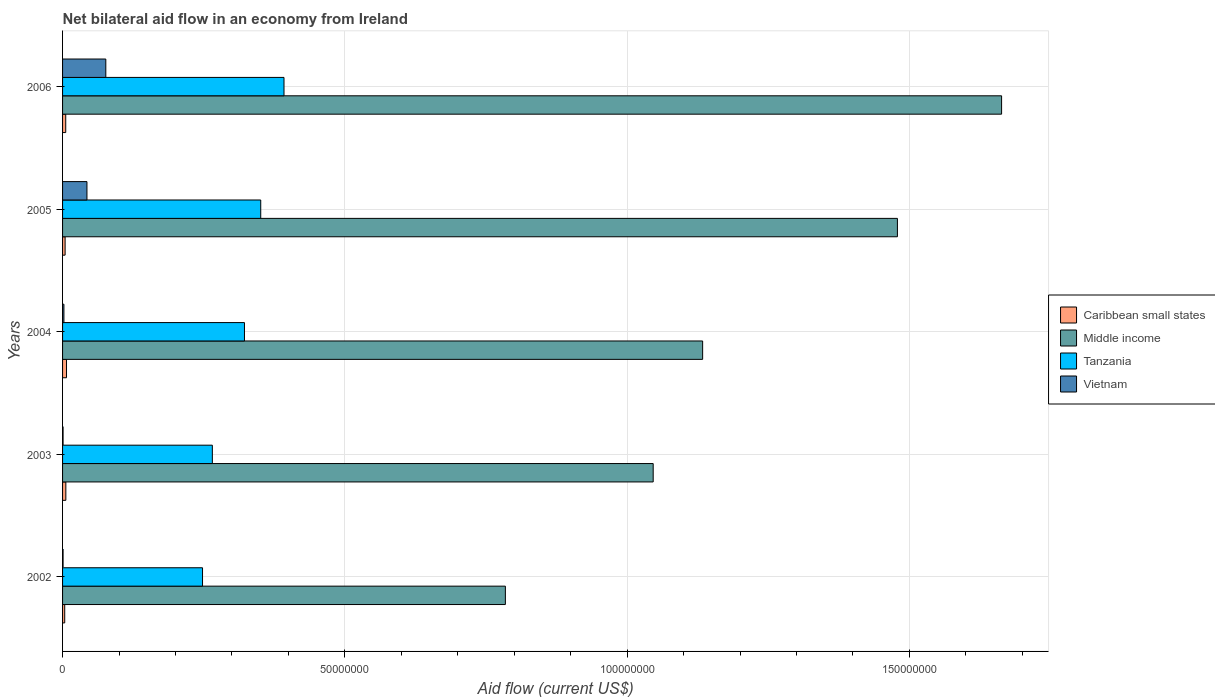How many bars are there on the 4th tick from the bottom?
Make the answer very short. 4. What is the label of the 5th group of bars from the top?
Your answer should be compact. 2002. In how many cases, is the number of bars for a given year not equal to the number of legend labels?
Your answer should be very brief. 0. What is the net bilateral aid flow in Middle income in 2003?
Ensure brevity in your answer.  1.05e+08. Across all years, what is the minimum net bilateral aid flow in Tanzania?
Ensure brevity in your answer.  2.48e+07. In which year was the net bilateral aid flow in Vietnam maximum?
Provide a succinct answer. 2006. In which year was the net bilateral aid flow in Tanzania minimum?
Provide a short and direct response. 2002. What is the total net bilateral aid flow in Tanzania in the graph?
Offer a very short reply. 1.58e+08. What is the difference between the net bilateral aid flow in Caribbean small states in 2002 and that in 2005?
Your answer should be very brief. -7.00e+04. What is the difference between the net bilateral aid flow in Tanzania in 2006 and the net bilateral aid flow in Caribbean small states in 2003?
Ensure brevity in your answer.  3.86e+07. What is the average net bilateral aid flow in Tanzania per year?
Offer a very short reply. 3.16e+07. In the year 2004, what is the difference between the net bilateral aid flow in Vietnam and net bilateral aid flow in Caribbean small states?
Offer a terse response. -4.60e+05. What is the ratio of the net bilateral aid flow in Middle income in 2005 to that in 2006?
Your answer should be compact. 0.89. Is the net bilateral aid flow in Vietnam in 2002 less than that in 2003?
Provide a short and direct response. No. What is the difference between the highest and the second highest net bilateral aid flow in Middle income?
Provide a succinct answer. 1.84e+07. What is the difference between the highest and the lowest net bilateral aid flow in Vietnam?
Your answer should be very brief. 7.57e+06. What does the 4th bar from the top in 2003 represents?
Keep it short and to the point. Caribbean small states. What does the 1st bar from the bottom in 2003 represents?
Keep it short and to the point. Caribbean small states. Are the values on the major ticks of X-axis written in scientific E-notation?
Keep it short and to the point. No. Does the graph contain any zero values?
Provide a short and direct response. No. Where does the legend appear in the graph?
Provide a succinct answer. Center right. How many legend labels are there?
Make the answer very short. 4. What is the title of the graph?
Keep it short and to the point. Net bilateral aid flow in an economy from Ireland. What is the Aid flow (current US$) in Caribbean small states in 2002?
Provide a succinct answer. 3.80e+05. What is the Aid flow (current US$) of Middle income in 2002?
Your answer should be very brief. 7.84e+07. What is the Aid flow (current US$) in Tanzania in 2002?
Give a very brief answer. 2.48e+07. What is the Aid flow (current US$) of Vietnam in 2002?
Provide a short and direct response. 9.00e+04. What is the Aid flow (current US$) of Caribbean small states in 2003?
Your response must be concise. 5.80e+05. What is the Aid flow (current US$) in Middle income in 2003?
Your response must be concise. 1.05e+08. What is the Aid flow (current US$) in Tanzania in 2003?
Ensure brevity in your answer.  2.65e+07. What is the Aid flow (current US$) of Vietnam in 2003?
Provide a short and direct response. 9.00e+04. What is the Aid flow (current US$) of Caribbean small states in 2004?
Provide a succinct answer. 7.00e+05. What is the Aid flow (current US$) of Middle income in 2004?
Ensure brevity in your answer.  1.13e+08. What is the Aid flow (current US$) of Tanzania in 2004?
Your response must be concise. 3.22e+07. What is the Aid flow (current US$) of Middle income in 2005?
Make the answer very short. 1.48e+08. What is the Aid flow (current US$) of Tanzania in 2005?
Keep it short and to the point. 3.51e+07. What is the Aid flow (current US$) of Vietnam in 2005?
Your answer should be very brief. 4.32e+06. What is the Aid flow (current US$) of Caribbean small states in 2006?
Your answer should be very brief. 5.60e+05. What is the Aid flow (current US$) of Middle income in 2006?
Keep it short and to the point. 1.66e+08. What is the Aid flow (current US$) of Tanzania in 2006?
Make the answer very short. 3.92e+07. What is the Aid flow (current US$) of Vietnam in 2006?
Ensure brevity in your answer.  7.66e+06. Across all years, what is the maximum Aid flow (current US$) in Caribbean small states?
Give a very brief answer. 7.00e+05. Across all years, what is the maximum Aid flow (current US$) in Middle income?
Your answer should be compact. 1.66e+08. Across all years, what is the maximum Aid flow (current US$) in Tanzania?
Your answer should be very brief. 3.92e+07. Across all years, what is the maximum Aid flow (current US$) in Vietnam?
Your response must be concise. 7.66e+06. Across all years, what is the minimum Aid flow (current US$) of Caribbean small states?
Keep it short and to the point. 3.80e+05. Across all years, what is the minimum Aid flow (current US$) of Middle income?
Give a very brief answer. 7.84e+07. Across all years, what is the minimum Aid flow (current US$) in Tanzania?
Give a very brief answer. 2.48e+07. Across all years, what is the minimum Aid flow (current US$) of Vietnam?
Keep it short and to the point. 9.00e+04. What is the total Aid flow (current US$) of Caribbean small states in the graph?
Offer a very short reply. 2.67e+06. What is the total Aid flow (current US$) of Middle income in the graph?
Provide a short and direct response. 6.11e+08. What is the total Aid flow (current US$) of Tanzania in the graph?
Offer a terse response. 1.58e+08. What is the total Aid flow (current US$) in Vietnam in the graph?
Make the answer very short. 1.24e+07. What is the difference between the Aid flow (current US$) in Middle income in 2002 and that in 2003?
Give a very brief answer. -2.62e+07. What is the difference between the Aid flow (current US$) in Tanzania in 2002 and that in 2003?
Make the answer very short. -1.74e+06. What is the difference between the Aid flow (current US$) in Caribbean small states in 2002 and that in 2004?
Give a very brief answer. -3.20e+05. What is the difference between the Aid flow (current US$) of Middle income in 2002 and that in 2004?
Provide a succinct answer. -3.49e+07. What is the difference between the Aid flow (current US$) of Tanzania in 2002 and that in 2004?
Give a very brief answer. -7.43e+06. What is the difference between the Aid flow (current US$) of Vietnam in 2002 and that in 2004?
Offer a very short reply. -1.50e+05. What is the difference between the Aid flow (current US$) of Caribbean small states in 2002 and that in 2005?
Give a very brief answer. -7.00e+04. What is the difference between the Aid flow (current US$) in Middle income in 2002 and that in 2005?
Offer a very short reply. -6.94e+07. What is the difference between the Aid flow (current US$) of Tanzania in 2002 and that in 2005?
Your answer should be compact. -1.03e+07. What is the difference between the Aid flow (current US$) of Vietnam in 2002 and that in 2005?
Ensure brevity in your answer.  -4.23e+06. What is the difference between the Aid flow (current US$) of Middle income in 2002 and that in 2006?
Keep it short and to the point. -8.79e+07. What is the difference between the Aid flow (current US$) in Tanzania in 2002 and that in 2006?
Provide a succinct answer. -1.44e+07. What is the difference between the Aid flow (current US$) in Vietnam in 2002 and that in 2006?
Keep it short and to the point. -7.57e+06. What is the difference between the Aid flow (current US$) of Caribbean small states in 2003 and that in 2004?
Your response must be concise. -1.20e+05. What is the difference between the Aid flow (current US$) in Middle income in 2003 and that in 2004?
Offer a very short reply. -8.76e+06. What is the difference between the Aid flow (current US$) in Tanzania in 2003 and that in 2004?
Your answer should be very brief. -5.69e+06. What is the difference between the Aid flow (current US$) in Middle income in 2003 and that in 2005?
Your answer should be compact. -4.33e+07. What is the difference between the Aid flow (current US$) of Tanzania in 2003 and that in 2005?
Provide a short and direct response. -8.57e+06. What is the difference between the Aid flow (current US$) of Vietnam in 2003 and that in 2005?
Offer a very short reply. -4.23e+06. What is the difference between the Aid flow (current US$) of Caribbean small states in 2003 and that in 2006?
Your response must be concise. 2.00e+04. What is the difference between the Aid flow (current US$) of Middle income in 2003 and that in 2006?
Keep it short and to the point. -6.17e+07. What is the difference between the Aid flow (current US$) in Tanzania in 2003 and that in 2006?
Provide a succinct answer. -1.27e+07. What is the difference between the Aid flow (current US$) in Vietnam in 2003 and that in 2006?
Provide a short and direct response. -7.57e+06. What is the difference between the Aid flow (current US$) of Middle income in 2004 and that in 2005?
Ensure brevity in your answer.  -3.45e+07. What is the difference between the Aid flow (current US$) in Tanzania in 2004 and that in 2005?
Offer a very short reply. -2.88e+06. What is the difference between the Aid flow (current US$) of Vietnam in 2004 and that in 2005?
Offer a very short reply. -4.08e+06. What is the difference between the Aid flow (current US$) of Middle income in 2004 and that in 2006?
Make the answer very short. -5.30e+07. What is the difference between the Aid flow (current US$) in Tanzania in 2004 and that in 2006?
Your answer should be very brief. -7.00e+06. What is the difference between the Aid flow (current US$) of Vietnam in 2004 and that in 2006?
Provide a short and direct response. -7.42e+06. What is the difference between the Aid flow (current US$) of Middle income in 2005 and that in 2006?
Give a very brief answer. -1.84e+07. What is the difference between the Aid flow (current US$) of Tanzania in 2005 and that in 2006?
Offer a terse response. -4.12e+06. What is the difference between the Aid flow (current US$) of Vietnam in 2005 and that in 2006?
Ensure brevity in your answer.  -3.34e+06. What is the difference between the Aid flow (current US$) in Caribbean small states in 2002 and the Aid flow (current US$) in Middle income in 2003?
Your answer should be very brief. -1.04e+08. What is the difference between the Aid flow (current US$) of Caribbean small states in 2002 and the Aid flow (current US$) of Tanzania in 2003?
Keep it short and to the point. -2.62e+07. What is the difference between the Aid flow (current US$) in Middle income in 2002 and the Aid flow (current US$) in Tanzania in 2003?
Give a very brief answer. 5.19e+07. What is the difference between the Aid flow (current US$) in Middle income in 2002 and the Aid flow (current US$) in Vietnam in 2003?
Keep it short and to the point. 7.83e+07. What is the difference between the Aid flow (current US$) in Tanzania in 2002 and the Aid flow (current US$) in Vietnam in 2003?
Keep it short and to the point. 2.47e+07. What is the difference between the Aid flow (current US$) of Caribbean small states in 2002 and the Aid flow (current US$) of Middle income in 2004?
Give a very brief answer. -1.13e+08. What is the difference between the Aid flow (current US$) of Caribbean small states in 2002 and the Aid flow (current US$) of Tanzania in 2004?
Provide a short and direct response. -3.18e+07. What is the difference between the Aid flow (current US$) in Middle income in 2002 and the Aid flow (current US$) in Tanzania in 2004?
Offer a very short reply. 4.62e+07. What is the difference between the Aid flow (current US$) in Middle income in 2002 and the Aid flow (current US$) in Vietnam in 2004?
Make the answer very short. 7.82e+07. What is the difference between the Aid flow (current US$) of Tanzania in 2002 and the Aid flow (current US$) of Vietnam in 2004?
Ensure brevity in your answer.  2.46e+07. What is the difference between the Aid flow (current US$) in Caribbean small states in 2002 and the Aid flow (current US$) in Middle income in 2005?
Ensure brevity in your answer.  -1.47e+08. What is the difference between the Aid flow (current US$) of Caribbean small states in 2002 and the Aid flow (current US$) of Tanzania in 2005?
Your answer should be very brief. -3.47e+07. What is the difference between the Aid flow (current US$) of Caribbean small states in 2002 and the Aid flow (current US$) of Vietnam in 2005?
Your answer should be compact. -3.94e+06. What is the difference between the Aid flow (current US$) in Middle income in 2002 and the Aid flow (current US$) in Tanzania in 2005?
Provide a short and direct response. 4.33e+07. What is the difference between the Aid flow (current US$) of Middle income in 2002 and the Aid flow (current US$) of Vietnam in 2005?
Your response must be concise. 7.41e+07. What is the difference between the Aid flow (current US$) of Tanzania in 2002 and the Aid flow (current US$) of Vietnam in 2005?
Keep it short and to the point. 2.05e+07. What is the difference between the Aid flow (current US$) in Caribbean small states in 2002 and the Aid flow (current US$) in Middle income in 2006?
Your answer should be compact. -1.66e+08. What is the difference between the Aid flow (current US$) of Caribbean small states in 2002 and the Aid flow (current US$) of Tanzania in 2006?
Your answer should be compact. -3.88e+07. What is the difference between the Aid flow (current US$) of Caribbean small states in 2002 and the Aid flow (current US$) of Vietnam in 2006?
Keep it short and to the point. -7.28e+06. What is the difference between the Aid flow (current US$) in Middle income in 2002 and the Aid flow (current US$) in Tanzania in 2006?
Offer a very short reply. 3.92e+07. What is the difference between the Aid flow (current US$) of Middle income in 2002 and the Aid flow (current US$) of Vietnam in 2006?
Your response must be concise. 7.08e+07. What is the difference between the Aid flow (current US$) of Tanzania in 2002 and the Aid flow (current US$) of Vietnam in 2006?
Keep it short and to the point. 1.71e+07. What is the difference between the Aid flow (current US$) in Caribbean small states in 2003 and the Aid flow (current US$) in Middle income in 2004?
Offer a terse response. -1.13e+08. What is the difference between the Aid flow (current US$) of Caribbean small states in 2003 and the Aid flow (current US$) of Tanzania in 2004?
Your response must be concise. -3.16e+07. What is the difference between the Aid flow (current US$) of Caribbean small states in 2003 and the Aid flow (current US$) of Vietnam in 2004?
Your answer should be very brief. 3.40e+05. What is the difference between the Aid flow (current US$) in Middle income in 2003 and the Aid flow (current US$) in Tanzania in 2004?
Give a very brief answer. 7.24e+07. What is the difference between the Aid flow (current US$) in Middle income in 2003 and the Aid flow (current US$) in Vietnam in 2004?
Keep it short and to the point. 1.04e+08. What is the difference between the Aid flow (current US$) of Tanzania in 2003 and the Aid flow (current US$) of Vietnam in 2004?
Provide a short and direct response. 2.63e+07. What is the difference between the Aid flow (current US$) of Caribbean small states in 2003 and the Aid flow (current US$) of Middle income in 2005?
Offer a very short reply. -1.47e+08. What is the difference between the Aid flow (current US$) of Caribbean small states in 2003 and the Aid flow (current US$) of Tanzania in 2005?
Keep it short and to the point. -3.45e+07. What is the difference between the Aid flow (current US$) of Caribbean small states in 2003 and the Aid flow (current US$) of Vietnam in 2005?
Your answer should be compact. -3.74e+06. What is the difference between the Aid flow (current US$) of Middle income in 2003 and the Aid flow (current US$) of Tanzania in 2005?
Ensure brevity in your answer.  6.95e+07. What is the difference between the Aid flow (current US$) in Middle income in 2003 and the Aid flow (current US$) in Vietnam in 2005?
Your answer should be compact. 1.00e+08. What is the difference between the Aid flow (current US$) in Tanzania in 2003 and the Aid flow (current US$) in Vietnam in 2005?
Make the answer very short. 2.22e+07. What is the difference between the Aid flow (current US$) of Caribbean small states in 2003 and the Aid flow (current US$) of Middle income in 2006?
Offer a terse response. -1.66e+08. What is the difference between the Aid flow (current US$) of Caribbean small states in 2003 and the Aid flow (current US$) of Tanzania in 2006?
Make the answer very short. -3.86e+07. What is the difference between the Aid flow (current US$) of Caribbean small states in 2003 and the Aid flow (current US$) of Vietnam in 2006?
Make the answer very short. -7.08e+06. What is the difference between the Aid flow (current US$) of Middle income in 2003 and the Aid flow (current US$) of Tanzania in 2006?
Provide a succinct answer. 6.54e+07. What is the difference between the Aid flow (current US$) in Middle income in 2003 and the Aid flow (current US$) in Vietnam in 2006?
Provide a short and direct response. 9.70e+07. What is the difference between the Aid flow (current US$) in Tanzania in 2003 and the Aid flow (current US$) in Vietnam in 2006?
Your answer should be very brief. 1.89e+07. What is the difference between the Aid flow (current US$) of Caribbean small states in 2004 and the Aid flow (current US$) of Middle income in 2005?
Keep it short and to the point. -1.47e+08. What is the difference between the Aid flow (current US$) of Caribbean small states in 2004 and the Aid flow (current US$) of Tanzania in 2005?
Give a very brief answer. -3.44e+07. What is the difference between the Aid flow (current US$) of Caribbean small states in 2004 and the Aid flow (current US$) of Vietnam in 2005?
Give a very brief answer. -3.62e+06. What is the difference between the Aid flow (current US$) in Middle income in 2004 and the Aid flow (current US$) in Tanzania in 2005?
Give a very brief answer. 7.83e+07. What is the difference between the Aid flow (current US$) in Middle income in 2004 and the Aid flow (current US$) in Vietnam in 2005?
Provide a succinct answer. 1.09e+08. What is the difference between the Aid flow (current US$) of Tanzania in 2004 and the Aid flow (current US$) of Vietnam in 2005?
Provide a succinct answer. 2.79e+07. What is the difference between the Aid flow (current US$) of Caribbean small states in 2004 and the Aid flow (current US$) of Middle income in 2006?
Give a very brief answer. -1.66e+08. What is the difference between the Aid flow (current US$) of Caribbean small states in 2004 and the Aid flow (current US$) of Tanzania in 2006?
Keep it short and to the point. -3.85e+07. What is the difference between the Aid flow (current US$) of Caribbean small states in 2004 and the Aid flow (current US$) of Vietnam in 2006?
Keep it short and to the point. -6.96e+06. What is the difference between the Aid flow (current US$) of Middle income in 2004 and the Aid flow (current US$) of Tanzania in 2006?
Your answer should be compact. 7.42e+07. What is the difference between the Aid flow (current US$) in Middle income in 2004 and the Aid flow (current US$) in Vietnam in 2006?
Your answer should be compact. 1.06e+08. What is the difference between the Aid flow (current US$) in Tanzania in 2004 and the Aid flow (current US$) in Vietnam in 2006?
Give a very brief answer. 2.46e+07. What is the difference between the Aid flow (current US$) in Caribbean small states in 2005 and the Aid flow (current US$) in Middle income in 2006?
Your answer should be very brief. -1.66e+08. What is the difference between the Aid flow (current US$) of Caribbean small states in 2005 and the Aid flow (current US$) of Tanzania in 2006?
Provide a succinct answer. -3.88e+07. What is the difference between the Aid flow (current US$) in Caribbean small states in 2005 and the Aid flow (current US$) in Vietnam in 2006?
Ensure brevity in your answer.  -7.21e+06. What is the difference between the Aid flow (current US$) of Middle income in 2005 and the Aid flow (current US$) of Tanzania in 2006?
Offer a terse response. 1.09e+08. What is the difference between the Aid flow (current US$) of Middle income in 2005 and the Aid flow (current US$) of Vietnam in 2006?
Provide a short and direct response. 1.40e+08. What is the difference between the Aid flow (current US$) of Tanzania in 2005 and the Aid flow (current US$) of Vietnam in 2006?
Offer a terse response. 2.74e+07. What is the average Aid flow (current US$) of Caribbean small states per year?
Your answer should be very brief. 5.34e+05. What is the average Aid flow (current US$) in Middle income per year?
Keep it short and to the point. 1.22e+08. What is the average Aid flow (current US$) in Tanzania per year?
Keep it short and to the point. 3.16e+07. What is the average Aid flow (current US$) of Vietnam per year?
Make the answer very short. 2.48e+06. In the year 2002, what is the difference between the Aid flow (current US$) in Caribbean small states and Aid flow (current US$) in Middle income?
Your answer should be compact. -7.80e+07. In the year 2002, what is the difference between the Aid flow (current US$) in Caribbean small states and Aid flow (current US$) in Tanzania?
Keep it short and to the point. -2.44e+07. In the year 2002, what is the difference between the Aid flow (current US$) in Caribbean small states and Aid flow (current US$) in Vietnam?
Ensure brevity in your answer.  2.90e+05. In the year 2002, what is the difference between the Aid flow (current US$) in Middle income and Aid flow (current US$) in Tanzania?
Offer a very short reply. 5.36e+07. In the year 2002, what is the difference between the Aid flow (current US$) in Middle income and Aid flow (current US$) in Vietnam?
Your response must be concise. 7.83e+07. In the year 2002, what is the difference between the Aid flow (current US$) of Tanzania and Aid flow (current US$) of Vietnam?
Keep it short and to the point. 2.47e+07. In the year 2003, what is the difference between the Aid flow (current US$) in Caribbean small states and Aid flow (current US$) in Middle income?
Provide a succinct answer. -1.04e+08. In the year 2003, what is the difference between the Aid flow (current US$) of Caribbean small states and Aid flow (current US$) of Tanzania?
Offer a very short reply. -2.60e+07. In the year 2003, what is the difference between the Aid flow (current US$) of Caribbean small states and Aid flow (current US$) of Vietnam?
Offer a very short reply. 4.90e+05. In the year 2003, what is the difference between the Aid flow (current US$) of Middle income and Aid flow (current US$) of Tanzania?
Your answer should be compact. 7.81e+07. In the year 2003, what is the difference between the Aid flow (current US$) in Middle income and Aid flow (current US$) in Vietnam?
Your answer should be very brief. 1.05e+08. In the year 2003, what is the difference between the Aid flow (current US$) of Tanzania and Aid flow (current US$) of Vietnam?
Ensure brevity in your answer.  2.64e+07. In the year 2004, what is the difference between the Aid flow (current US$) of Caribbean small states and Aid flow (current US$) of Middle income?
Offer a very short reply. -1.13e+08. In the year 2004, what is the difference between the Aid flow (current US$) of Caribbean small states and Aid flow (current US$) of Tanzania?
Give a very brief answer. -3.15e+07. In the year 2004, what is the difference between the Aid flow (current US$) in Middle income and Aid flow (current US$) in Tanzania?
Make the answer very short. 8.12e+07. In the year 2004, what is the difference between the Aid flow (current US$) in Middle income and Aid flow (current US$) in Vietnam?
Provide a short and direct response. 1.13e+08. In the year 2004, what is the difference between the Aid flow (current US$) in Tanzania and Aid flow (current US$) in Vietnam?
Give a very brief answer. 3.20e+07. In the year 2005, what is the difference between the Aid flow (current US$) of Caribbean small states and Aid flow (current US$) of Middle income?
Offer a very short reply. -1.47e+08. In the year 2005, what is the difference between the Aid flow (current US$) in Caribbean small states and Aid flow (current US$) in Tanzania?
Ensure brevity in your answer.  -3.46e+07. In the year 2005, what is the difference between the Aid flow (current US$) of Caribbean small states and Aid flow (current US$) of Vietnam?
Make the answer very short. -3.87e+06. In the year 2005, what is the difference between the Aid flow (current US$) of Middle income and Aid flow (current US$) of Tanzania?
Your answer should be very brief. 1.13e+08. In the year 2005, what is the difference between the Aid flow (current US$) in Middle income and Aid flow (current US$) in Vietnam?
Offer a very short reply. 1.44e+08. In the year 2005, what is the difference between the Aid flow (current US$) of Tanzania and Aid flow (current US$) of Vietnam?
Give a very brief answer. 3.08e+07. In the year 2006, what is the difference between the Aid flow (current US$) of Caribbean small states and Aid flow (current US$) of Middle income?
Offer a terse response. -1.66e+08. In the year 2006, what is the difference between the Aid flow (current US$) of Caribbean small states and Aid flow (current US$) of Tanzania?
Make the answer very short. -3.87e+07. In the year 2006, what is the difference between the Aid flow (current US$) of Caribbean small states and Aid flow (current US$) of Vietnam?
Offer a terse response. -7.10e+06. In the year 2006, what is the difference between the Aid flow (current US$) in Middle income and Aid flow (current US$) in Tanzania?
Offer a terse response. 1.27e+08. In the year 2006, what is the difference between the Aid flow (current US$) in Middle income and Aid flow (current US$) in Vietnam?
Offer a very short reply. 1.59e+08. In the year 2006, what is the difference between the Aid flow (current US$) in Tanzania and Aid flow (current US$) in Vietnam?
Your response must be concise. 3.16e+07. What is the ratio of the Aid flow (current US$) of Caribbean small states in 2002 to that in 2003?
Offer a terse response. 0.66. What is the ratio of the Aid flow (current US$) in Middle income in 2002 to that in 2003?
Make the answer very short. 0.75. What is the ratio of the Aid flow (current US$) of Tanzania in 2002 to that in 2003?
Provide a succinct answer. 0.93. What is the ratio of the Aid flow (current US$) in Caribbean small states in 2002 to that in 2004?
Provide a succinct answer. 0.54. What is the ratio of the Aid flow (current US$) in Middle income in 2002 to that in 2004?
Offer a very short reply. 0.69. What is the ratio of the Aid flow (current US$) of Tanzania in 2002 to that in 2004?
Provide a succinct answer. 0.77. What is the ratio of the Aid flow (current US$) in Caribbean small states in 2002 to that in 2005?
Offer a very short reply. 0.84. What is the ratio of the Aid flow (current US$) of Middle income in 2002 to that in 2005?
Provide a short and direct response. 0.53. What is the ratio of the Aid flow (current US$) in Tanzania in 2002 to that in 2005?
Give a very brief answer. 0.71. What is the ratio of the Aid flow (current US$) in Vietnam in 2002 to that in 2005?
Keep it short and to the point. 0.02. What is the ratio of the Aid flow (current US$) in Caribbean small states in 2002 to that in 2006?
Offer a very short reply. 0.68. What is the ratio of the Aid flow (current US$) of Middle income in 2002 to that in 2006?
Provide a short and direct response. 0.47. What is the ratio of the Aid flow (current US$) of Tanzania in 2002 to that in 2006?
Provide a short and direct response. 0.63. What is the ratio of the Aid flow (current US$) in Vietnam in 2002 to that in 2006?
Offer a terse response. 0.01. What is the ratio of the Aid flow (current US$) in Caribbean small states in 2003 to that in 2004?
Your response must be concise. 0.83. What is the ratio of the Aid flow (current US$) in Middle income in 2003 to that in 2004?
Provide a succinct answer. 0.92. What is the ratio of the Aid flow (current US$) in Tanzania in 2003 to that in 2004?
Make the answer very short. 0.82. What is the ratio of the Aid flow (current US$) of Caribbean small states in 2003 to that in 2005?
Ensure brevity in your answer.  1.29. What is the ratio of the Aid flow (current US$) of Middle income in 2003 to that in 2005?
Keep it short and to the point. 0.71. What is the ratio of the Aid flow (current US$) of Tanzania in 2003 to that in 2005?
Offer a terse response. 0.76. What is the ratio of the Aid flow (current US$) in Vietnam in 2003 to that in 2005?
Provide a short and direct response. 0.02. What is the ratio of the Aid flow (current US$) in Caribbean small states in 2003 to that in 2006?
Ensure brevity in your answer.  1.04. What is the ratio of the Aid flow (current US$) in Middle income in 2003 to that in 2006?
Your answer should be compact. 0.63. What is the ratio of the Aid flow (current US$) of Tanzania in 2003 to that in 2006?
Make the answer very short. 0.68. What is the ratio of the Aid flow (current US$) of Vietnam in 2003 to that in 2006?
Offer a very short reply. 0.01. What is the ratio of the Aid flow (current US$) in Caribbean small states in 2004 to that in 2005?
Keep it short and to the point. 1.56. What is the ratio of the Aid flow (current US$) of Middle income in 2004 to that in 2005?
Keep it short and to the point. 0.77. What is the ratio of the Aid flow (current US$) in Tanzania in 2004 to that in 2005?
Offer a terse response. 0.92. What is the ratio of the Aid flow (current US$) of Vietnam in 2004 to that in 2005?
Ensure brevity in your answer.  0.06. What is the ratio of the Aid flow (current US$) in Middle income in 2004 to that in 2006?
Offer a very short reply. 0.68. What is the ratio of the Aid flow (current US$) in Tanzania in 2004 to that in 2006?
Offer a very short reply. 0.82. What is the ratio of the Aid flow (current US$) in Vietnam in 2004 to that in 2006?
Your response must be concise. 0.03. What is the ratio of the Aid flow (current US$) of Caribbean small states in 2005 to that in 2006?
Ensure brevity in your answer.  0.8. What is the ratio of the Aid flow (current US$) of Middle income in 2005 to that in 2006?
Provide a short and direct response. 0.89. What is the ratio of the Aid flow (current US$) of Tanzania in 2005 to that in 2006?
Ensure brevity in your answer.  0.9. What is the ratio of the Aid flow (current US$) in Vietnam in 2005 to that in 2006?
Give a very brief answer. 0.56. What is the difference between the highest and the second highest Aid flow (current US$) of Caribbean small states?
Make the answer very short. 1.20e+05. What is the difference between the highest and the second highest Aid flow (current US$) in Middle income?
Your response must be concise. 1.84e+07. What is the difference between the highest and the second highest Aid flow (current US$) of Tanzania?
Make the answer very short. 4.12e+06. What is the difference between the highest and the second highest Aid flow (current US$) of Vietnam?
Provide a short and direct response. 3.34e+06. What is the difference between the highest and the lowest Aid flow (current US$) in Caribbean small states?
Offer a terse response. 3.20e+05. What is the difference between the highest and the lowest Aid flow (current US$) in Middle income?
Offer a terse response. 8.79e+07. What is the difference between the highest and the lowest Aid flow (current US$) of Tanzania?
Your answer should be compact. 1.44e+07. What is the difference between the highest and the lowest Aid flow (current US$) of Vietnam?
Your response must be concise. 7.57e+06. 